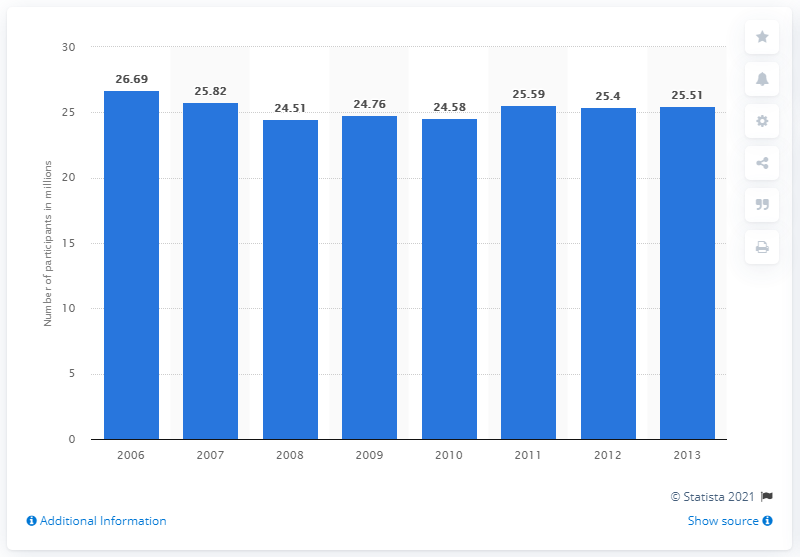Identify some key points in this picture. The number of participants in home gym exercises in 2012 was 25.51. 